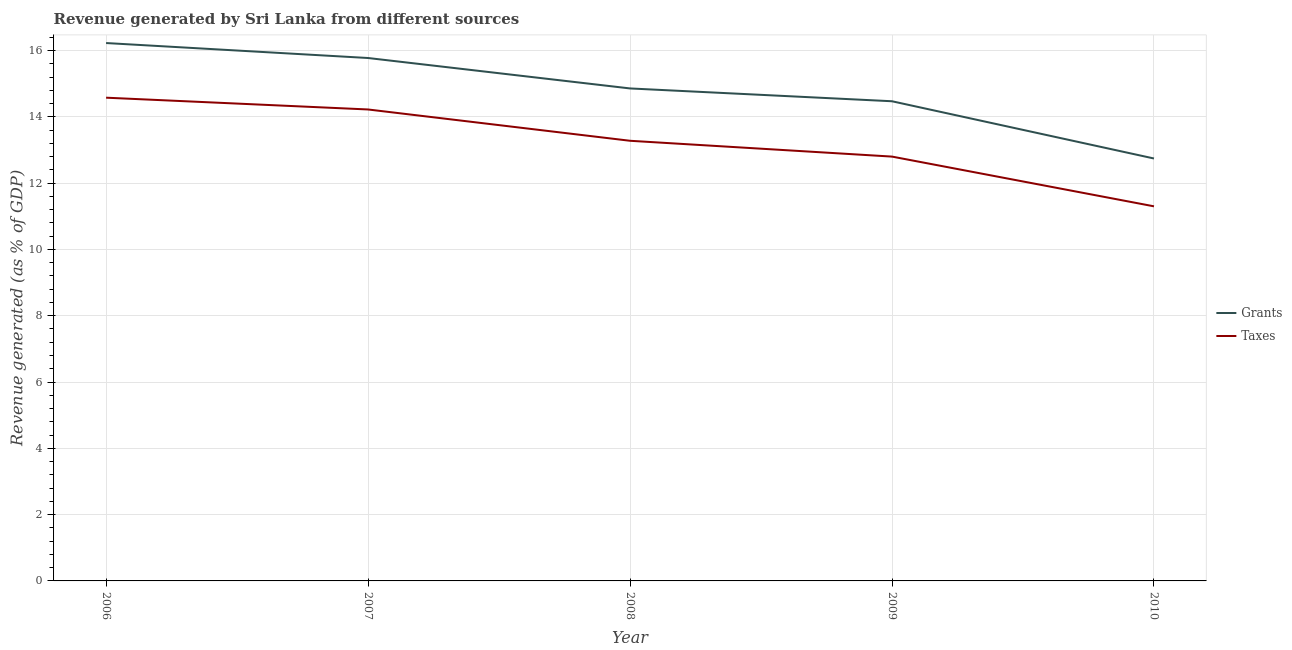How many different coloured lines are there?
Your response must be concise. 2. Is the number of lines equal to the number of legend labels?
Provide a short and direct response. Yes. What is the revenue generated by grants in 2008?
Provide a short and direct response. 14.86. Across all years, what is the maximum revenue generated by grants?
Keep it short and to the point. 16.23. Across all years, what is the minimum revenue generated by grants?
Make the answer very short. 12.74. In which year was the revenue generated by grants minimum?
Offer a very short reply. 2010. What is the total revenue generated by taxes in the graph?
Make the answer very short. 66.18. What is the difference between the revenue generated by taxes in 2007 and that in 2008?
Keep it short and to the point. 0.94. What is the difference between the revenue generated by taxes in 2007 and the revenue generated by grants in 2010?
Make the answer very short. 1.48. What is the average revenue generated by taxes per year?
Provide a succinct answer. 13.24. In the year 2009, what is the difference between the revenue generated by taxes and revenue generated by grants?
Give a very brief answer. -1.67. What is the ratio of the revenue generated by taxes in 2007 to that in 2010?
Your response must be concise. 1.26. What is the difference between the highest and the second highest revenue generated by grants?
Provide a succinct answer. 0.45. What is the difference between the highest and the lowest revenue generated by grants?
Keep it short and to the point. 3.48. In how many years, is the revenue generated by taxes greater than the average revenue generated by taxes taken over all years?
Your answer should be compact. 3. Is the sum of the revenue generated by grants in 2009 and 2010 greater than the maximum revenue generated by taxes across all years?
Make the answer very short. Yes. Does the revenue generated by taxes monotonically increase over the years?
Offer a terse response. No. Is the revenue generated by taxes strictly greater than the revenue generated by grants over the years?
Make the answer very short. No. How many lines are there?
Offer a terse response. 2. How many years are there in the graph?
Ensure brevity in your answer.  5. What is the difference between two consecutive major ticks on the Y-axis?
Keep it short and to the point. 2. How many legend labels are there?
Offer a terse response. 2. What is the title of the graph?
Offer a very short reply. Revenue generated by Sri Lanka from different sources. What is the label or title of the Y-axis?
Your answer should be compact. Revenue generated (as % of GDP). What is the Revenue generated (as % of GDP) in Grants in 2006?
Offer a very short reply. 16.23. What is the Revenue generated (as % of GDP) in Taxes in 2006?
Offer a very short reply. 14.58. What is the Revenue generated (as % of GDP) of Grants in 2007?
Provide a succinct answer. 15.77. What is the Revenue generated (as % of GDP) in Taxes in 2007?
Your answer should be very brief. 14.22. What is the Revenue generated (as % of GDP) in Grants in 2008?
Provide a short and direct response. 14.86. What is the Revenue generated (as % of GDP) of Taxes in 2008?
Your response must be concise. 13.28. What is the Revenue generated (as % of GDP) of Grants in 2009?
Make the answer very short. 14.47. What is the Revenue generated (as % of GDP) of Taxes in 2009?
Your answer should be compact. 12.8. What is the Revenue generated (as % of GDP) in Grants in 2010?
Make the answer very short. 12.74. What is the Revenue generated (as % of GDP) in Taxes in 2010?
Offer a terse response. 11.3. Across all years, what is the maximum Revenue generated (as % of GDP) in Grants?
Ensure brevity in your answer.  16.23. Across all years, what is the maximum Revenue generated (as % of GDP) of Taxes?
Make the answer very short. 14.58. Across all years, what is the minimum Revenue generated (as % of GDP) in Grants?
Provide a short and direct response. 12.74. Across all years, what is the minimum Revenue generated (as % of GDP) of Taxes?
Your answer should be very brief. 11.3. What is the total Revenue generated (as % of GDP) of Grants in the graph?
Make the answer very short. 74.07. What is the total Revenue generated (as % of GDP) in Taxes in the graph?
Ensure brevity in your answer.  66.18. What is the difference between the Revenue generated (as % of GDP) of Grants in 2006 and that in 2007?
Give a very brief answer. 0.45. What is the difference between the Revenue generated (as % of GDP) of Taxes in 2006 and that in 2007?
Give a very brief answer. 0.36. What is the difference between the Revenue generated (as % of GDP) in Grants in 2006 and that in 2008?
Provide a short and direct response. 1.37. What is the difference between the Revenue generated (as % of GDP) in Taxes in 2006 and that in 2008?
Offer a very short reply. 1.3. What is the difference between the Revenue generated (as % of GDP) of Grants in 2006 and that in 2009?
Offer a terse response. 1.76. What is the difference between the Revenue generated (as % of GDP) in Taxes in 2006 and that in 2009?
Provide a short and direct response. 1.78. What is the difference between the Revenue generated (as % of GDP) of Grants in 2006 and that in 2010?
Your response must be concise. 3.48. What is the difference between the Revenue generated (as % of GDP) in Taxes in 2006 and that in 2010?
Your answer should be compact. 3.28. What is the difference between the Revenue generated (as % of GDP) of Grants in 2007 and that in 2008?
Ensure brevity in your answer.  0.92. What is the difference between the Revenue generated (as % of GDP) of Taxes in 2007 and that in 2008?
Provide a short and direct response. 0.94. What is the difference between the Revenue generated (as % of GDP) in Grants in 2007 and that in 2009?
Your answer should be compact. 1.3. What is the difference between the Revenue generated (as % of GDP) in Taxes in 2007 and that in 2009?
Ensure brevity in your answer.  1.42. What is the difference between the Revenue generated (as % of GDP) of Grants in 2007 and that in 2010?
Make the answer very short. 3.03. What is the difference between the Revenue generated (as % of GDP) of Taxes in 2007 and that in 2010?
Your answer should be very brief. 2.92. What is the difference between the Revenue generated (as % of GDP) of Grants in 2008 and that in 2009?
Give a very brief answer. 0.39. What is the difference between the Revenue generated (as % of GDP) of Taxes in 2008 and that in 2009?
Give a very brief answer. 0.48. What is the difference between the Revenue generated (as % of GDP) in Grants in 2008 and that in 2010?
Your answer should be very brief. 2.11. What is the difference between the Revenue generated (as % of GDP) in Taxes in 2008 and that in 2010?
Provide a succinct answer. 1.98. What is the difference between the Revenue generated (as % of GDP) in Grants in 2009 and that in 2010?
Ensure brevity in your answer.  1.73. What is the difference between the Revenue generated (as % of GDP) in Taxes in 2009 and that in 2010?
Give a very brief answer. 1.5. What is the difference between the Revenue generated (as % of GDP) of Grants in 2006 and the Revenue generated (as % of GDP) of Taxes in 2007?
Give a very brief answer. 2. What is the difference between the Revenue generated (as % of GDP) in Grants in 2006 and the Revenue generated (as % of GDP) in Taxes in 2008?
Your answer should be very brief. 2.95. What is the difference between the Revenue generated (as % of GDP) in Grants in 2006 and the Revenue generated (as % of GDP) in Taxes in 2009?
Your answer should be compact. 3.43. What is the difference between the Revenue generated (as % of GDP) in Grants in 2006 and the Revenue generated (as % of GDP) in Taxes in 2010?
Your response must be concise. 4.93. What is the difference between the Revenue generated (as % of GDP) in Grants in 2007 and the Revenue generated (as % of GDP) in Taxes in 2008?
Your response must be concise. 2.5. What is the difference between the Revenue generated (as % of GDP) in Grants in 2007 and the Revenue generated (as % of GDP) in Taxes in 2009?
Give a very brief answer. 2.97. What is the difference between the Revenue generated (as % of GDP) in Grants in 2007 and the Revenue generated (as % of GDP) in Taxes in 2010?
Make the answer very short. 4.47. What is the difference between the Revenue generated (as % of GDP) of Grants in 2008 and the Revenue generated (as % of GDP) of Taxes in 2009?
Offer a terse response. 2.06. What is the difference between the Revenue generated (as % of GDP) in Grants in 2008 and the Revenue generated (as % of GDP) in Taxes in 2010?
Make the answer very short. 3.56. What is the difference between the Revenue generated (as % of GDP) of Grants in 2009 and the Revenue generated (as % of GDP) of Taxes in 2010?
Offer a terse response. 3.17. What is the average Revenue generated (as % of GDP) in Grants per year?
Give a very brief answer. 14.81. What is the average Revenue generated (as % of GDP) of Taxes per year?
Give a very brief answer. 13.24. In the year 2006, what is the difference between the Revenue generated (as % of GDP) of Grants and Revenue generated (as % of GDP) of Taxes?
Ensure brevity in your answer.  1.65. In the year 2007, what is the difference between the Revenue generated (as % of GDP) in Grants and Revenue generated (as % of GDP) in Taxes?
Give a very brief answer. 1.55. In the year 2008, what is the difference between the Revenue generated (as % of GDP) in Grants and Revenue generated (as % of GDP) in Taxes?
Your response must be concise. 1.58. In the year 2009, what is the difference between the Revenue generated (as % of GDP) of Grants and Revenue generated (as % of GDP) of Taxes?
Provide a succinct answer. 1.67. In the year 2010, what is the difference between the Revenue generated (as % of GDP) of Grants and Revenue generated (as % of GDP) of Taxes?
Give a very brief answer. 1.44. What is the ratio of the Revenue generated (as % of GDP) in Grants in 2006 to that in 2007?
Make the answer very short. 1.03. What is the ratio of the Revenue generated (as % of GDP) of Grants in 2006 to that in 2008?
Your response must be concise. 1.09. What is the ratio of the Revenue generated (as % of GDP) of Taxes in 2006 to that in 2008?
Ensure brevity in your answer.  1.1. What is the ratio of the Revenue generated (as % of GDP) in Grants in 2006 to that in 2009?
Ensure brevity in your answer.  1.12. What is the ratio of the Revenue generated (as % of GDP) in Taxes in 2006 to that in 2009?
Give a very brief answer. 1.14. What is the ratio of the Revenue generated (as % of GDP) in Grants in 2006 to that in 2010?
Your answer should be very brief. 1.27. What is the ratio of the Revenue generated (as % of GDP) of Taxes in 2006 to that in 2010?
Keep it short and to the point. 1.29. What is the ratio of the Revenue generated (as % of GDP) in Grants in 2007 to that in 2008?
Offer a very short reply. 1.06. What is the ratio of the Revenue generated (as % of GDP) of Taxes in 2007 to that in 2008?
Keep it short and to the point. 1.07. What is the ratio of the Revenue generated (as % of GDP) in Grants in 2007 to that in 2009?
Your answer should be very brief. 1.09. What is the ratio of the Revenue generated (as % of GDP) of Taxes in 2007 to that in 2009?
Keep it short and to the point. 1.11. What is the ratio of the Revenue generated (as % of GDP) of Grants in 2007 to that in 2010?
Your response must be concise. 1.24. What is the ratio of the Revenue generated (as % of GDP) in Taxes in 2007 to that in 2010?
Ensure brevity in your answer.  1.26. What is the ratio of the Revenue generated (as % of GDP) of Grants in 2008 to that in 2009?
Your answer should be compact. 1.03. What is the ratio of the Revenue generated (as % of GDP) of Taxes in 2008 to that in 2009?
Provide a succinct answer. 1.04. What is the ratio of the Revenue generated (as % of GDP) in Grants in 2008 to that in 2010?
Offer a terse response. 1.17. What is the ratio of the Revenue generated (as % of GDP) of Taxes in 2008 to that in 2010?
Your answer should be compact. 1.18. What is the ratio of the Revenue generated (as % of GDP) in Grants in 2009 to that in 2010?
Keep it short and to the point. 1.14. What is the ratio of the Revenue generated (as % of GDP) of Taxes in 2009 to that in 2010?
Your response must be concise. 1.13. What is the difference between the highest and the second highest Revenue generated (as % of GDP) of Grants?
Provide a succinct answer. 0.45. What is the difference between the highest and the second highest Revenue generated (as % of GDP) of Taxes?
Your answer should be compact. 0.36. What is the difference between the highest and the lowest Revenue generated (as % of GDP) in Grants?
Provide a succinct answer. 3.48. What is the difference between the highest and the lowest Revenue generated (as % of GDP) in Taxes?
Give a very brief answer. 3.28. 